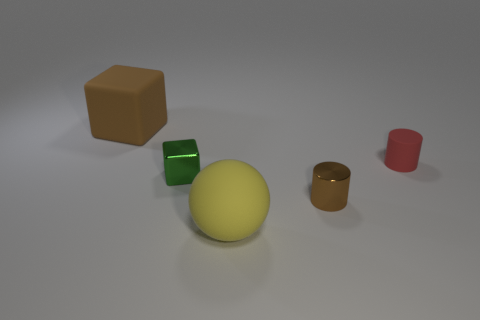What number of things are tiny brown metal cylinders that are in front of the brown block or red cylinders?
Your response must be concise. 2. What color is the small matte thing that is the same shape as the brown metal thing?
Keep it short and to the point. Red. Do the green metal object and the matte object that is to the right of the large sphere have the same shape?
Offer a terse response. No. What number of things are either red things that are behind the big yellow matte object or rubber things behind the big yellow rubber object?
Provide a short and direct response. 2. Are there fewer brown metallic cylinders on the left side of the brown matte block than tiny green spheres?
Offer a very short reply. No. Does the green object have the same material as the brown thing that is in front of the brown matte cube?
Offer a very short reply. Yes. What is the small green object made of?
Your response must be concise. Metal. There is a brown thing to the right of the big thing that is in front of the big object that is behind the green object; what is it made of?
Offer a very short reply. Metal. Does the matte cube have the same color as the metal object right of the big yellow thing?
Keep it short and to the point. Yes. Is there any other thing that is the same shape as the large yellow rubber thing?
Offer a terse response. No. 